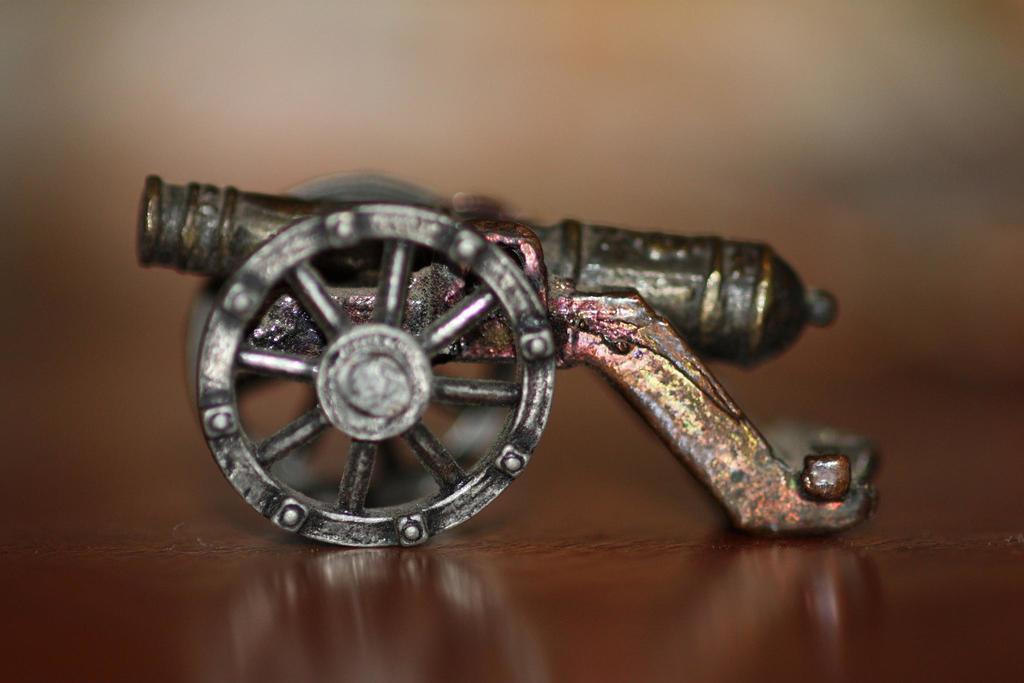Could you give a brief overview of what you see in this image? In the picture we can see a metallic structure of war weapon on the cart which is placed on the table. 